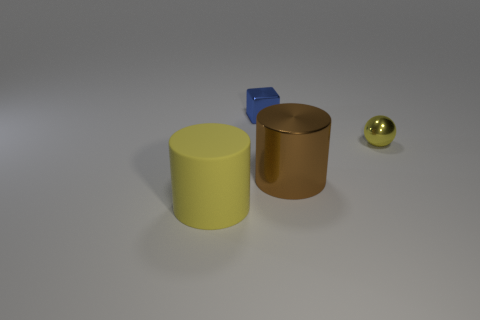Add 2 big green rubber spheres. How many objects exist? 6 Subtract all balls. How many objects are left? 3 Subtract all large blue cylinders. Subtract all yellow metallic objects. How many objects are left? 3 Add 1 large yellow matte objects. How many large yellow matte objects are left? 2 Add 1 large brown cylinders. How many large brown cylinders exist? 2 Subtract 0 red balls. How many objects are left? 4 